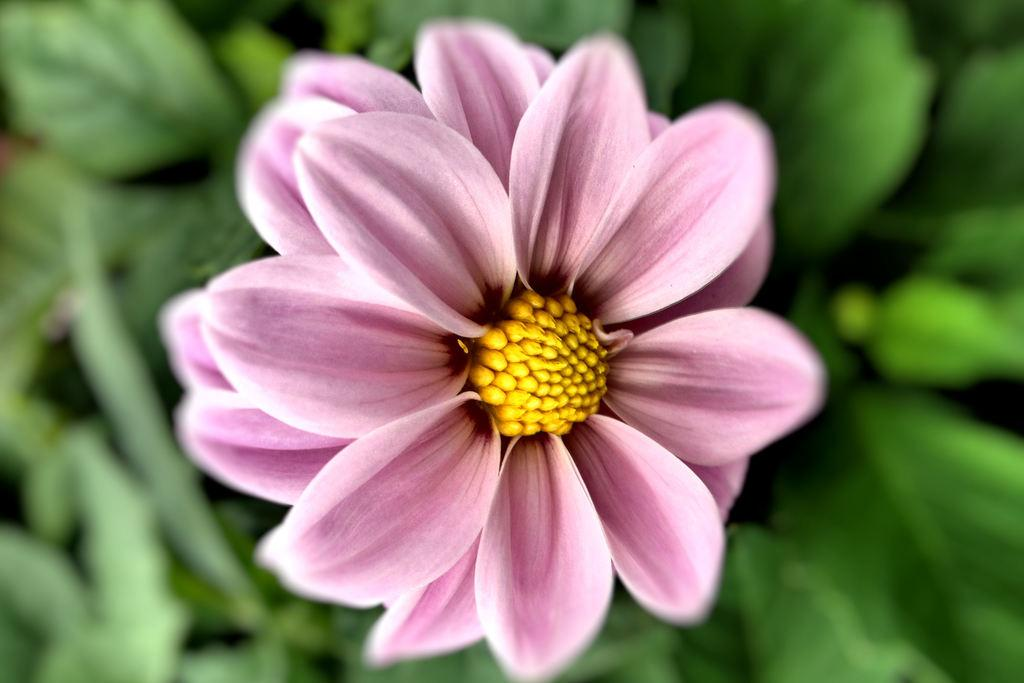What is the main subject of the image? The main subject of the image is planets. Are there any other objects or elements in the image besides the planets? Yes, there is a flower in the image. Can you describe the appearance of the flower? The flower is pink and yellow in color. What type of art is displayed on the moon in the image? There is no moon present in the image, and therefore no art on the moon. 